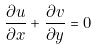<formula> <loc_0><loc_0><loc_500><loc_500>\frac { \partial u } { \partial x } + \frac { \partial v } { \partial y } = 0</formula> 